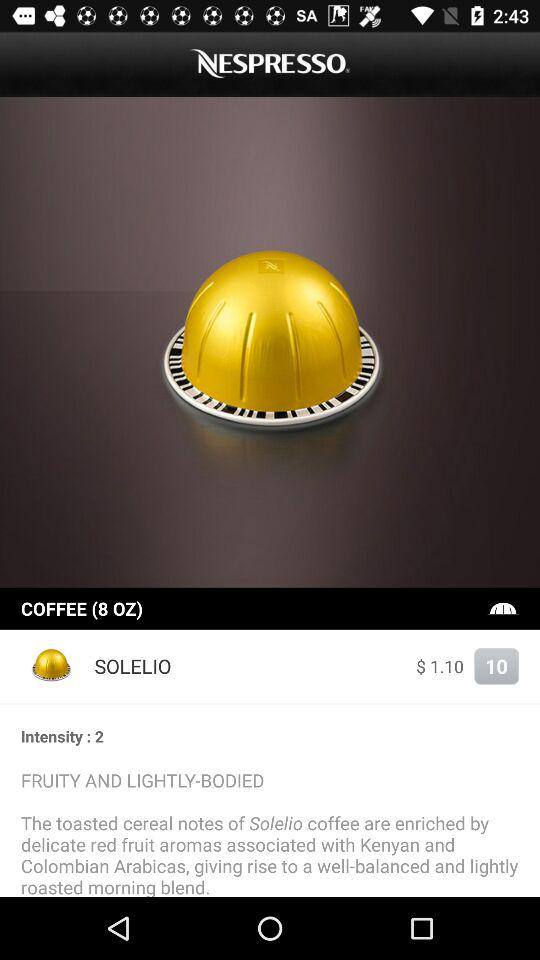How much off is the discount?
When the provided information is insufficient, respond with <no answer>. <no answer> 